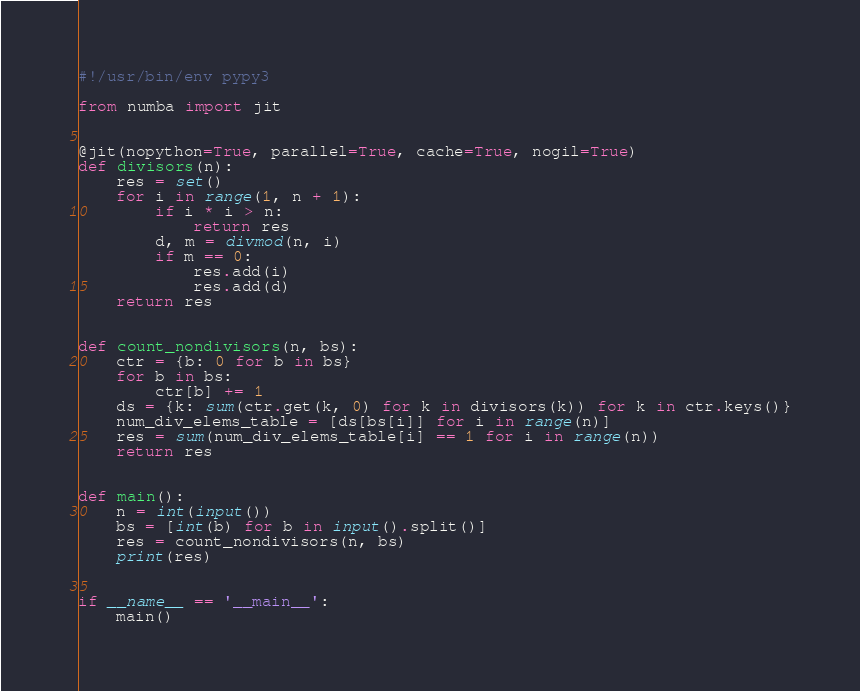<code> <loc_0><loc_0><loc_500><loc_500><_Python_>#!/usr/bin/env pypy3

from numba import jit


@jit(nopython=True, parallel=True, cache=True, nogil=True)
def divisors(n):
    res = set()
    for i in range(1, n + 1):
        if i * i > n:
            return res
        d, m = divmod(n, i)
        if m == 0:
            res.add(i)
            res.add(d)
    return res


def count_nondivisors(n, bs):
    ctr = {b: 0 for b in bs}
    for b in bs:
        ctr[b] += 1
    ds = {k: sum(ctr.get(k, 0) for k in divisors(k)) for k in ctr.keys()}
    num_div_elems_table = [ds[bs[i]] for i in range(n)]
    res = sum(num_div_elems_table[i] == 1 for i in range(n))
    return res


def main():
    n = int(input())
    bs = [int(b) for b in input().split()]
    res = count_nondivisors(n, bs)
    print(res)


if __name__ == '__main__':
    main()
</code> 